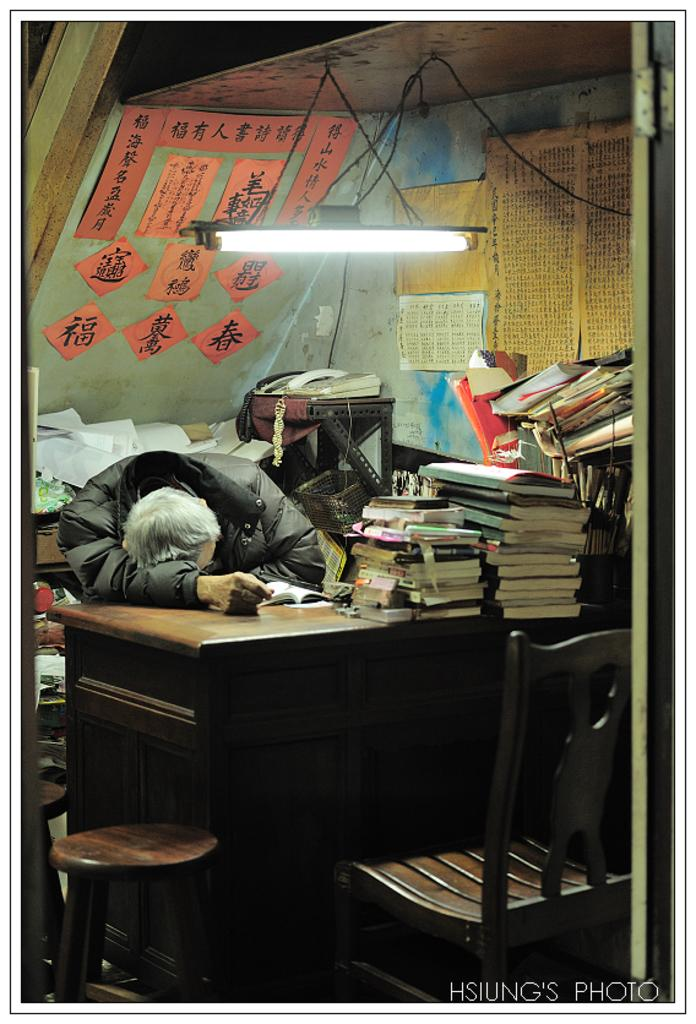What is the man doing in the image? The man is laying on the table. What object is also present on the table? There is a telephone on the table. What can be used to provide illumination in the image? There is a light on the table. What items can be seen for reading or learning purposes? There are books on the table. What type of furniture is visible in the image? There are chairs in the image. What type of field can be seen in the image? There is no field present in the image; it features a man laying on a table with various objects around him. What type of calculator is visible on the table? There is no calculator present in the image. 